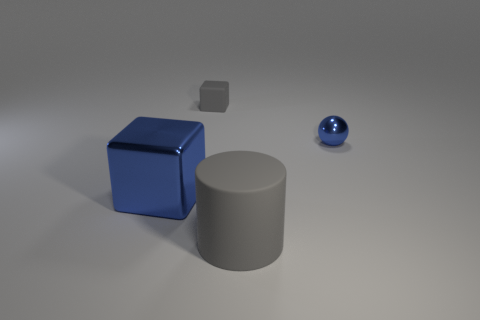What is the material of the blue thing on the left side of the gray thing in front of the tiny blue shiny object?
Provide a short and direct response. Metal. Are there any blocks behind the small blue thing?
Give a very brief answer. Yes. Is the number of small blocks that are to the right of the large gray cylinder greater than the number of metal blocks?
Your response must be concise. No. Are there any large cylinders that have the same color as the shiny ball?
Keep it short and to the point. No. The cube that is the same size as the cylinder is what color?
Ensure brevity in your answer.  Blue. There is a shiny object that is on the right side of the cylinder; is there a tiny gray object that is to the left of it?
Provide a succinct answer. Yes. There is a tiny thing that is on the left side of the big gray cylinder; what material is it?
Offer a terse response. Rubber. Are the small object that is on the right side of the big matte thing and the large object that is on the left side of the gray cylinder made of the same material?
Offer a terse response. Yes. Are there the same number of rubber cylinders in front of the big gray cylinder and blue metal blocks that are to the right of the large blue cube?
Your answer should be very brief. Yes. How many blue spheres have the same material as the blue block?
Provide a short and direct response. 1. 